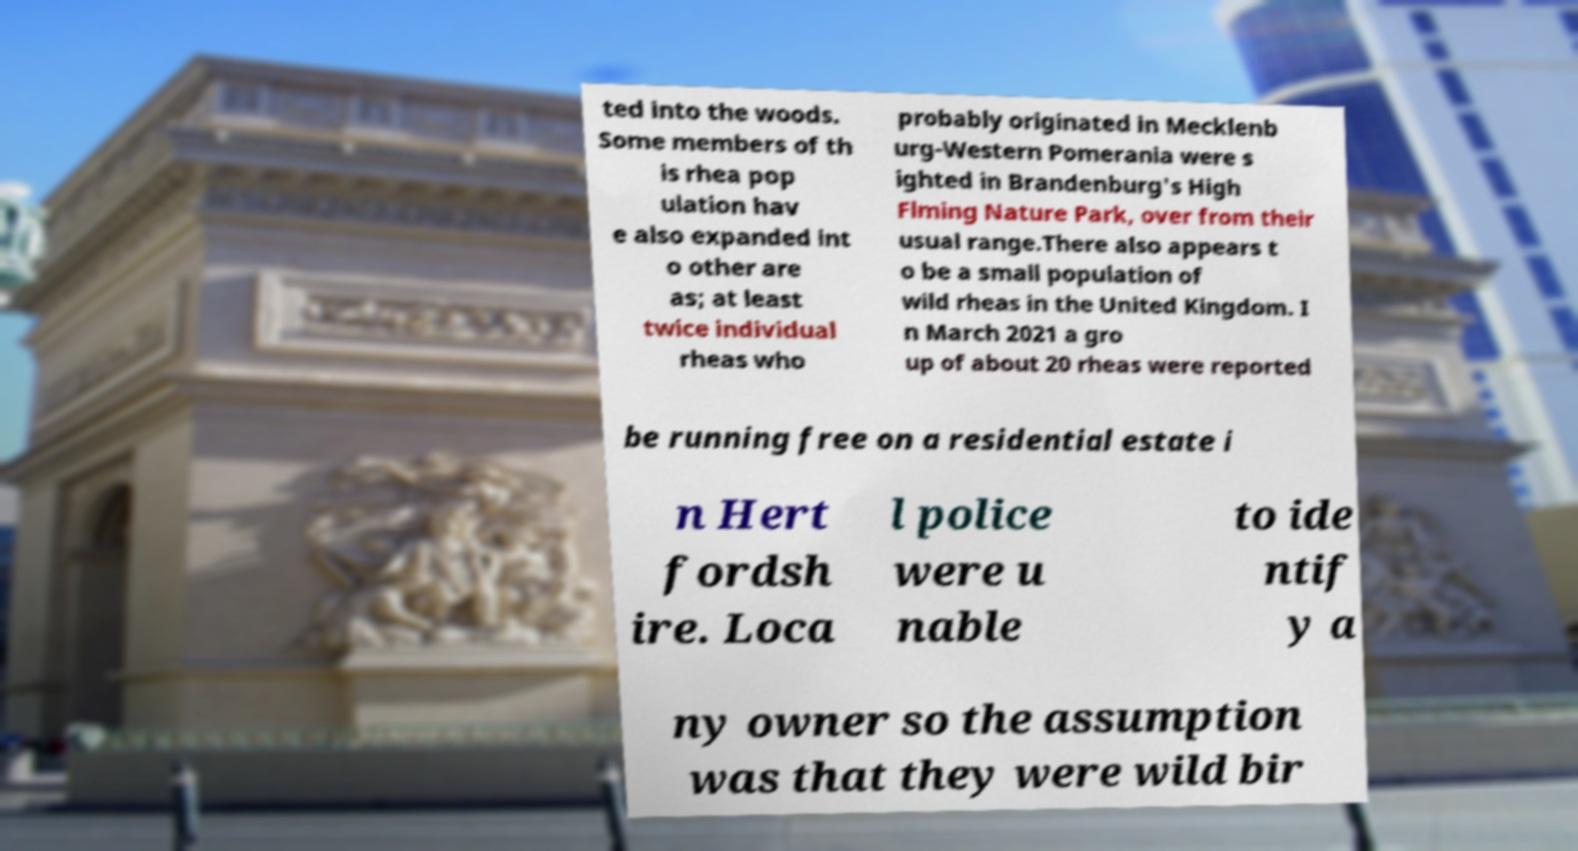Could you extract and type out the text from this image? ted into the woods. Some members of th is rhea pop ulation hav e also expanded int o other are as; at least twice individual rheas who probably originated in Mecklenb urg-Western Pomerania were s ighted in Brandenburg's High Flming Nature Park, over from their usual range.There also appears t o be a small population of wild rheas in the United Kingdom. I n March 2021 a gro up of about 20 rheas were reported be running free on a residential estate i n Hert fordsh ire. Loca l police were u nable to ide ntif y a ny owner so the assumption was that they were wild bir 